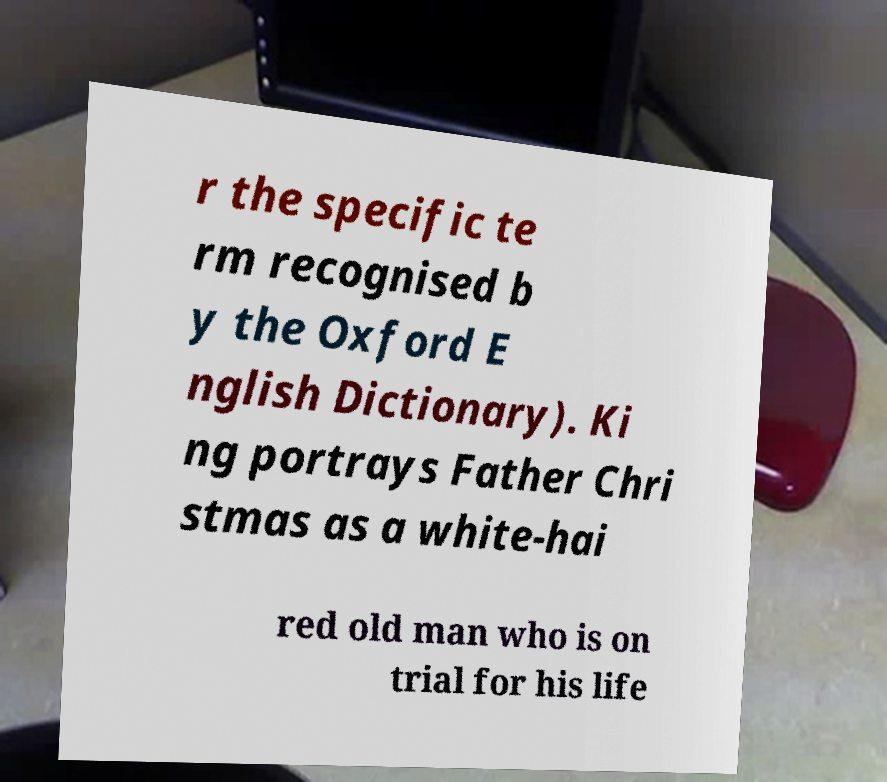There's text embedded in this image that I need extracted. Can you transcribe it verbatim? r the specific te rm recognised b y the Oxford E nglish Dictionary). Ki ng portrays Father Chri stmas as a white-hai red old man who is on trial for his life 